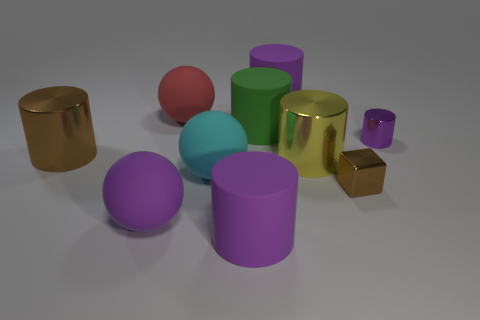How many purple cylinders must be subtracted to get 1 purple cylinders? 2 Subtract all cyan spheres. How many purple cylinders are left? 3 Subtract all purple rubber cylinders. How many cylinders are left? 4 Subtract all green cylinders. How many cylinders are left? 5 Subtract 3 cylinders. How many cylinders are left? 3 Subtract all red cylinders. Subtract all red cubes. How many cylinders are left? 6 Subtract all cubes. How many objects are left? 9 Add 3 big cyan rubber spheres. How many big cyan rubber spheres exist? 4 Subtract 0 red blocks. How many objects are left? 10 Subtract all tiny blocks. Subtract all large cyan matte objects. How many objects are left? 8 